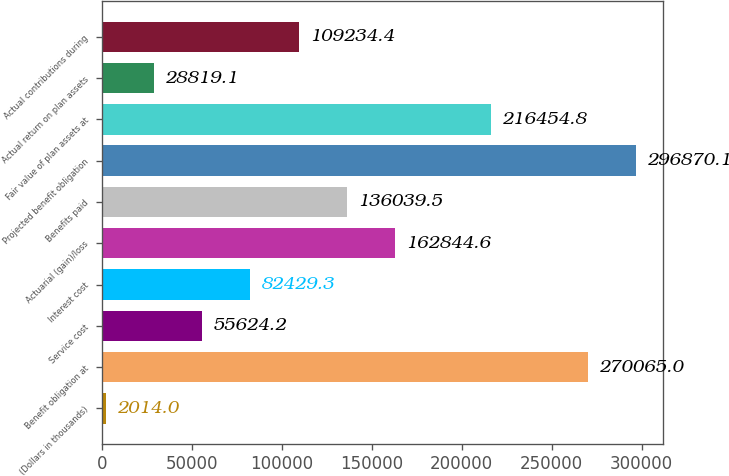Convert chart to OTSL. <chart><loc_0><loc_0><loc_500><loc_500><bar_chart><fcel>(Dollars in thousands)<fcel>Benefit obligation at<fcel>Service cost<fcel>Interest cost<fcel>Actuarial (gain)/loss<fcel>Benefits paid<fcel>Projected benefit obligation<fcel>Fair value of plan assets at<fcel>Actual return on plan assets<fcel>Actual contributions during<nl><fcel>2014<fcel>270065<fcel>55624.2<fcel>82429.3<fcel>162845<fcel>136040<fcel>296870<fcel>216455<fcel>28819.1<fcel>109234<nl></chart> 